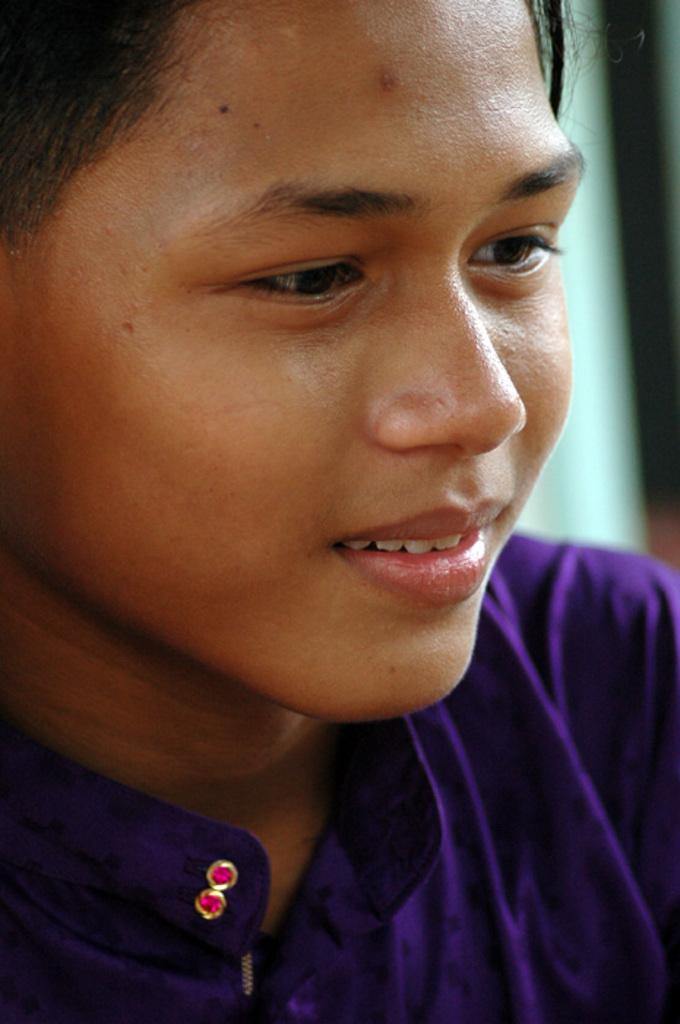Who is the main subject in the image? There is a girl in the image. What is the girl wearing? The girl is wearing a purple dress. Can you describe the background of the image? The background of the image appears blurry. What type of stamp can be seen on the girl's dress in the image? There is no stamp visible on the girl's dress in the image. What kind of feast is being prepared in the background of the image? There is no feast being prepared in the image; the background is blurry and does not show any specific activity. 